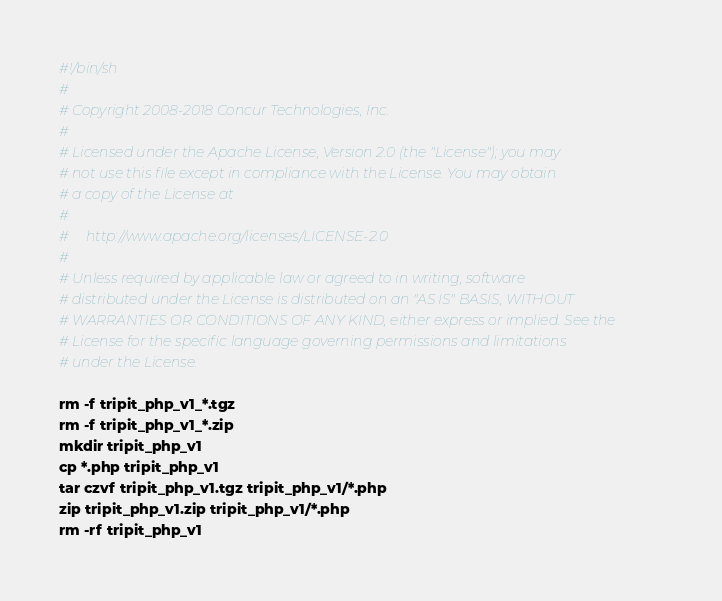<code> <loc_0><loc_0><loc_500><loc_500><_Bash_>#!/bin/sh
#
# Copyright 2008-2018 Concur Technologies, Inc.
#
# Licensed under the Apache License, Version 2.0 (the "License"); you may
# not use this file except in compliance with the License. You may obtain
# a copy of the License at
#
#     http://www.apache.org/licenses/LICENSE-2.0
#
# Unless required by applicable law or agreed to in writing, software
# distributed under the License is distributed on an "AS IS" BASIS, WITHOUT
# WARRANTIES OR CONDITIONS OF ANY KIND, either express or implied. See the
# License for the specific language governing permissions and limitations
# under the License.

rm -f tripit_php_v1_*.tgz
rm -f tripit_php_v1_*.zip
mkdir tripit_php_v1
cp *.php tripit_php_v1
tar czvf tripit_php_v1.tgz tripit_php_v1/*.php
zip tripit_php_v1.zip tripit_php_v1/*.php
rm -rf tripit_php_v1
</code> 